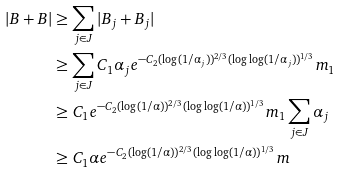Convert formula to latex. <formula><loc_0><loc_0><loc_500><loc_500>| B + B | & \geq \sum _ { j \in J } | B _ { j } + B _ { j } | \\ & \geq \sum _ { j \in J } C _ { 1 } \alpha _ { j } e ^ { - C _ { 2 } ( \log ( 1 / \alpha _ { j } ) ) ^ { 2 / 3 } ( \log \log ( 1 / \alpha _ { j } ) ) ^ { 1 / 3 } } m _ { 1 } \\ & \geq C _ { 1 } e ^ { - C _ { 2 } ( \log ( 1 / \alpha ) ) ^ { 2 / 3 } ( \log \log ( 1 / \alpha ) ) ^ { 1 / 3 } } m _ { 1 } \sum _ { j \in J } \alpha _ { j } \\ & \geq C _ { 1 } \alpha e ^ { - C _ { 2 } ( \log ( 1 / \alpha ) ) ^ { 2 / 3 } ( \log \log ( 1 / \alpha ) ) ^ { 1 / 3 } } m</formula> 